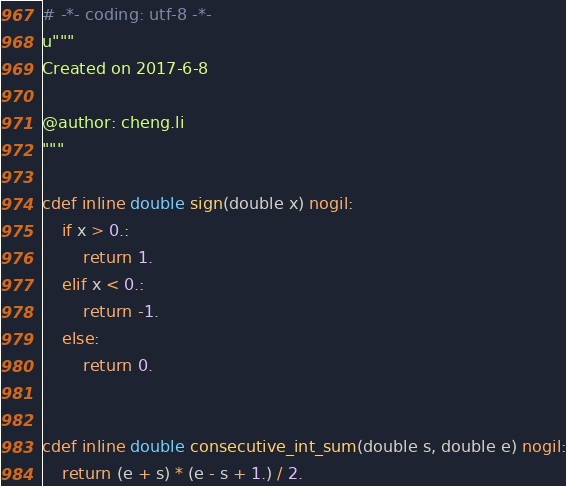Convert code to text. <code><loc_0><loc_0><loc_500><loc_500><_Cython_># -*- coding: utf-8 -*-
u"""
Created on 2017-6-8

@author: cheng.li
"""

cdef inline double sign(double x) nogil:
    if x > 0.:
        return 1.
    elif x < 0.:
        return -1.
    else:
        return 0.


cdef inline double consecutive_int_sum(double s, double e) nogil:
    return (e + s) * (e - s + 1.) / 2.
</code> 